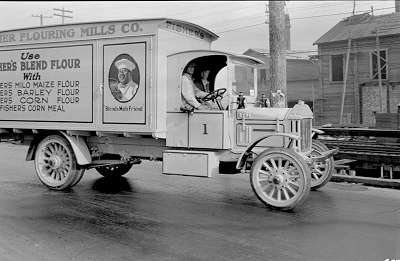Describe the objects in this image and their specific colors. I can see truck in black, darkgray, gray, and lightgray tones, people in black, darkgray, lightgray, and gray tones, people in black, gray, darkgray, and lightgray tones, and people in black, gray, darkgray, and lightgray tones in this image. 